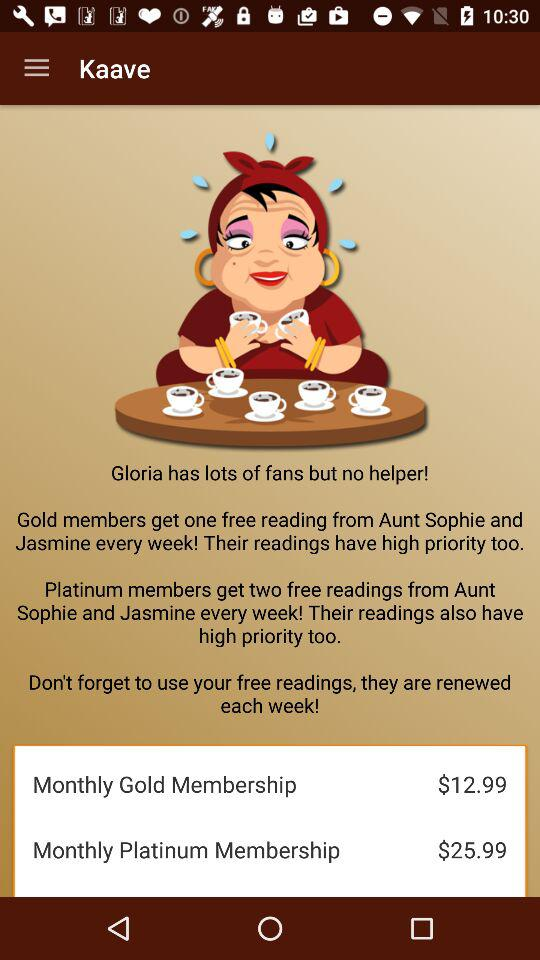What is the price of the monthly platinum membership? The price of the monthly platinum membership is $25.99. 